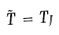<formula> <loc_0><loc_0><loc_500><loc_500>\tilde { T } = T _ { J }</formula> 